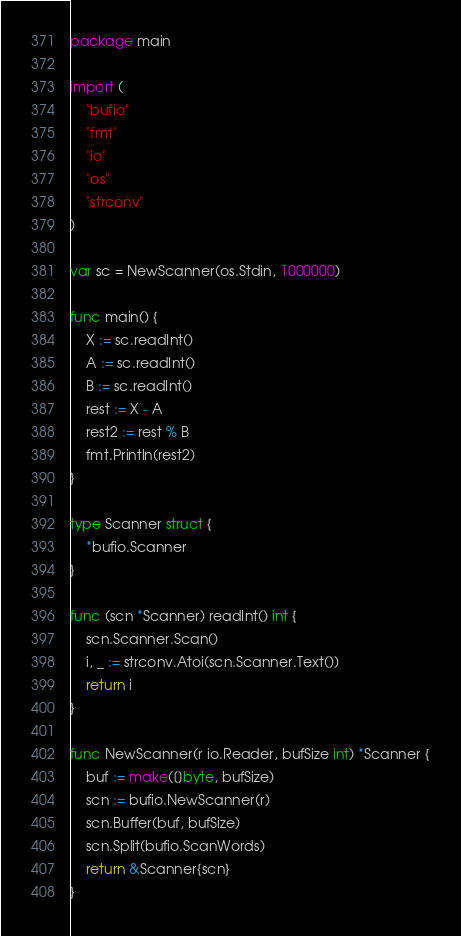Convert code to text. <code><loc_0><loc_0><loc_500><loc_500><_Go_>package main

import (
	"bufio"
	"fmt"
	"io"
	"os"
	"strconv"
)

var sc = NewScanner(os.Stdin, 1000000)

func main() {
	X := sc.readInt()
	A := sc.readInt()
	B := sc.readInt()
	rest := X - A
	rest2 := rest % B
	fmt.Println(rest2)
}

type Scanner struct {
	*bufio.Scanner
}

func (scn *Scanner) readInt() int {
	scn.Scanner.Scan()
	i, _ := strconv.Atoi(scn.Scanner.Text())
	return i
}

func NewScanner(r io.Reader, bufSize int) *Scanner {
	buf := make([]byte, bufSize)
	scn := bufio.NewScanner(r)
	scn.Buffer(buf, bufSize)
	scn.Split(bufio.ScanWords)
	return &Scanner{scn}
}
</code> 